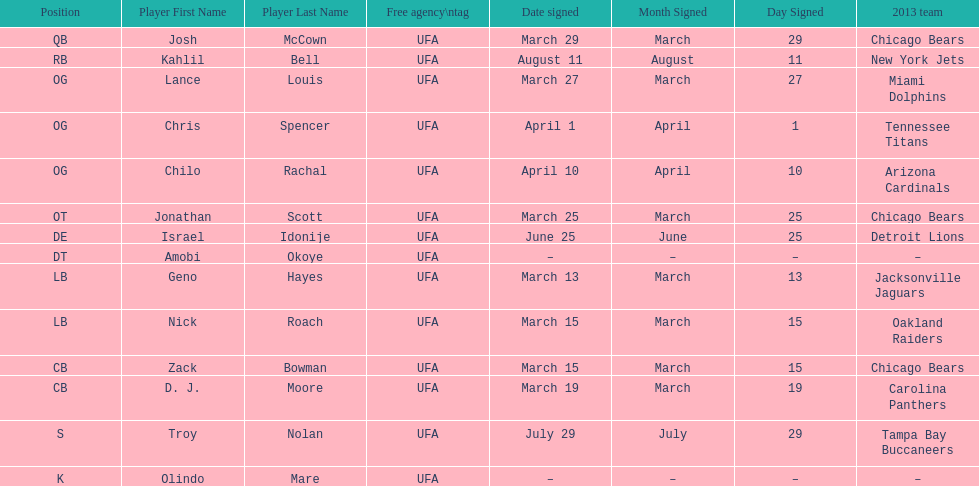Total number of players that signed in march? 7. 